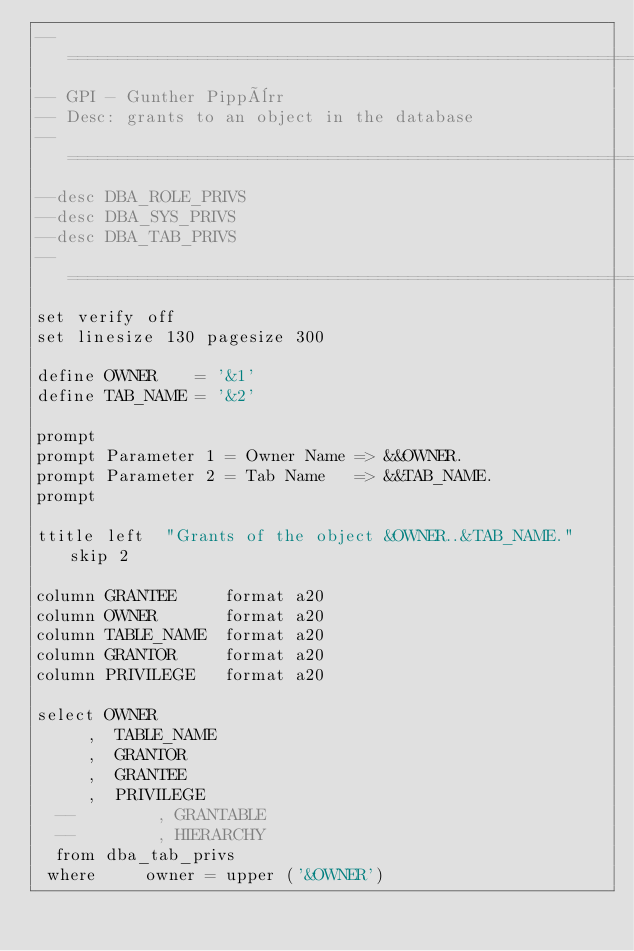Convert code to text. <code><loc_0><loc_0><loc_500><loc_500><_SQL_>--==============================================================================
-- GPI - Gunther Pippèrr
-- Desc: grants to an object in the database
--==============================================================================
--desc DBA_ROLE_PRIVS
--desc DBA_SYS_PRIVS
--desc DBA_TAB_PRIVS
--==============================================================================
set verify off
set linesize 130 pagesize 300 

define OWNER    = '&1'
define TAB_NAME = '&2'

prompt
prompt Parameter 1 = Owner Name => &&OWNER.
prompt Parameter 2 = Tab Name   => &&TAB_NAME.
prompt

ttitle left  "Grants of the object &OWNER..&TAB_NAME." skip 2

column GRANTEE     format a20
column OWNER       format a20
column TABLE_NAME  format a20
column GRANTOR     format a20
column PRIVILEGE   format a20

select OWNER
     ,  TABLE_NAME
     ,  GRANTOR
     ,  GRANTEE
     ,  PRIVILEGE
  --        , GRANTABLE
  --        , HIERARCHY
  from dba_tab_privs
 where     owner = upper ('&OWNER')</code> 